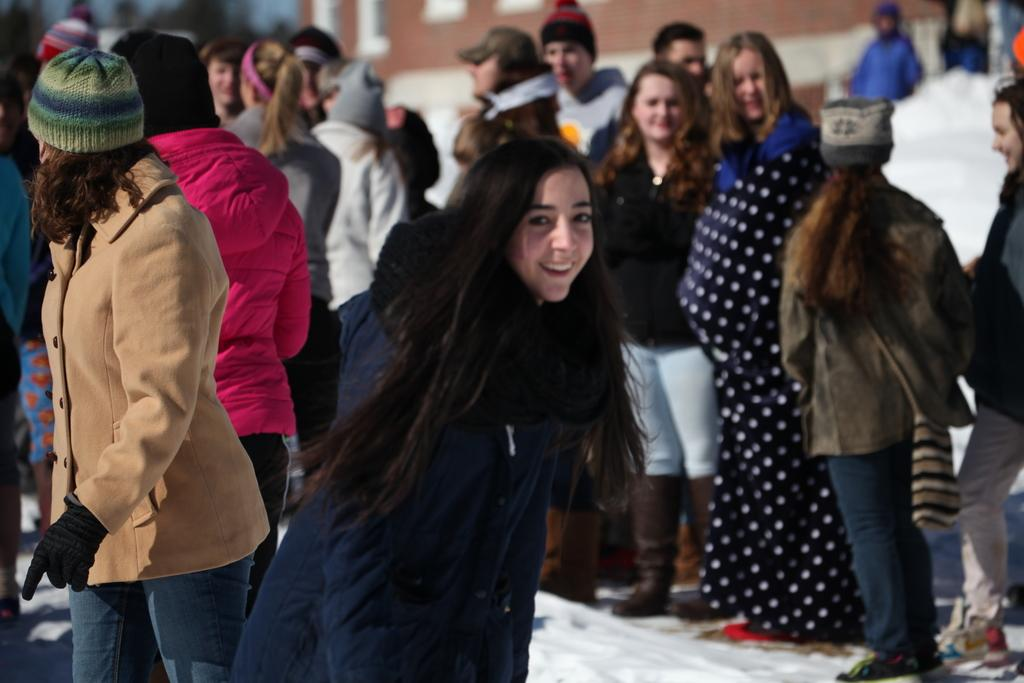Who or what can be seen in the image? There are people in the image. What is the environment like in the image? The people are in snow. What can be seen in the background of the image? There is a building in the background of the image. What is the name of the vessel they are using to travel in the snow? There is no vessel present in the image, as the people are simply standing or walking in the snow. 